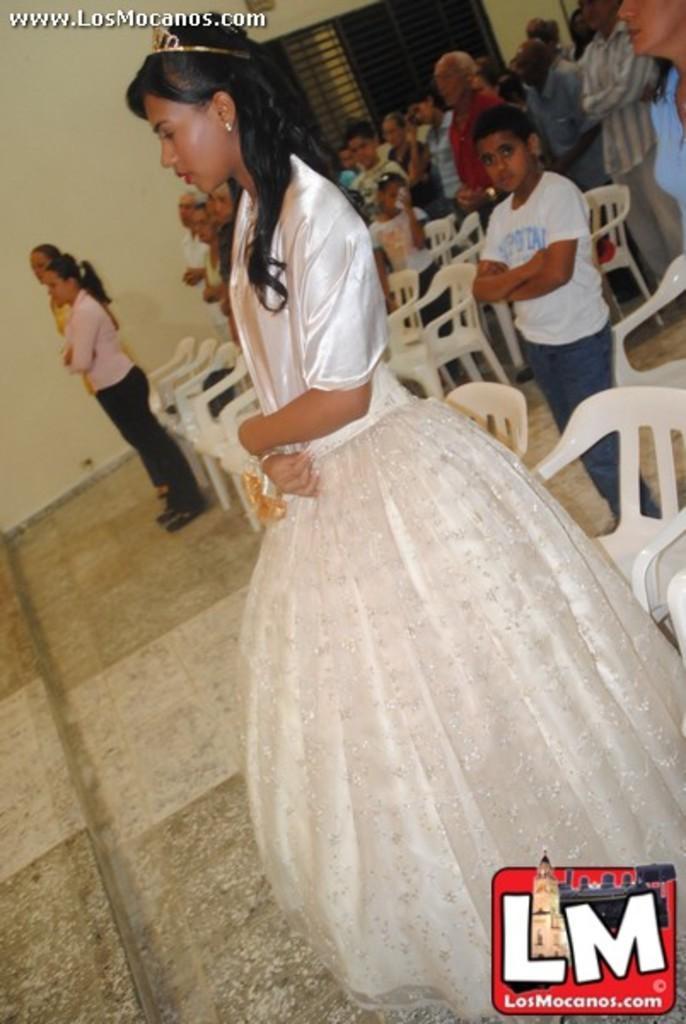Describe this image in one or two sentences. In this image there are people standing on a floor and there are chairs, in the background there is a wall, for that wall there is a window, in the top left there is text, in the bottom right there is a logo. 